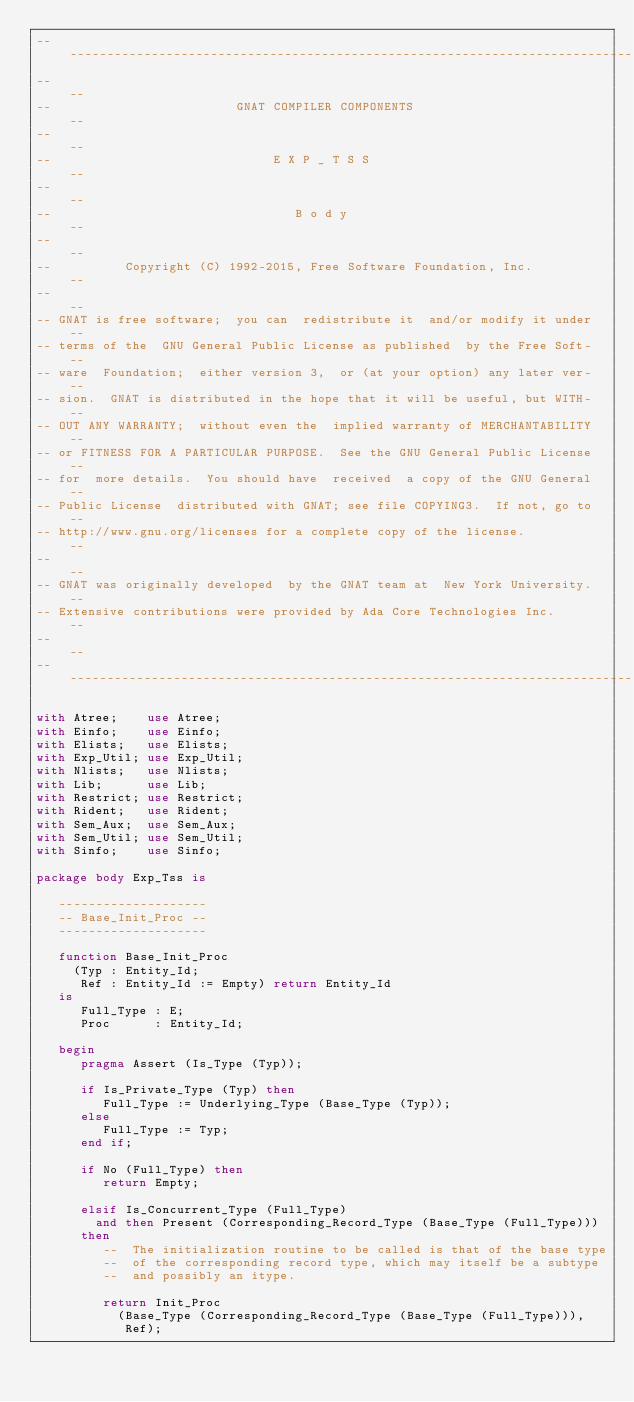<code> <loc_0><loc_0><loc_500><loc_500><_Ada_>------------------------------------------------------------------------------
--                                                                          --
--                         GNAT COMPILER COMPONENTS                         --
--                                                                          --
--                              E X P _ T S S                               --
--                                                                          --
--                                 B o d y                                  --
--                                                                          --
--          Copyright (C) 1992-2015, Free Software Foundation, Inc.         --
--                                                                          --
-- GNAT is free software;  you can  redistribute it  and/or modify it under --
-- terms of the  GNU General Public License as published  by the Free Soft- --
-- ware  Foundation;  either version 3,  or (at your option) any later ver- --
-- sion.  GNAT is distributed in the hope that it will be useful, but WITH- --
-- OUT ANY WARRANTY;  without even the  implied warranty of MERCHANTABILITY --
-- or FITNESS FOR A PARTICULAR PURPOSE.  See the GNU General Public License --
-- for  more details.  You should have  received  a copy of the GNU General --
-- Public License  distributed with GNAT; see file COPYING3.  If not, go to --
-- http://www.gnu.org/licenses for a complete copy of the license.          --
--                                                                          --
-- GNAT was originally developed  by the GNAT team at  New York University. --
-- Extensive contributions were provided by Ada Core Technologies Inc.      --
--                                                                          --
------------------------------------------------------------------------------

with Atree;    use Atree;
with Einfo;    use Einfo;
with Elists;   use Elists;
with Exp_Util; use Exp_Util;
with Nlists;   use Nlists;
with Lib;      use Lib;
with Restrict; use Restrict;
with Rident;   use Rident;
with Sem_Aux;  use Sem_Aux;
with Sem_Util; use Sem_Util;
with Sinfo;    use Sinfo;

package body Exp_Tss is

   --------------------
   -- Base_Init_Proc --
   --------------------

   function Base_Init_Proc
     (Typ : Entity_Id;
      Ref : Entity_Id := Empty) return Entity_Id
   is
      Full_Type : E;
      Proc      : Entity_Id;

   begin
      pragma Assert (Is_Type (Typ));

      if Is_Private_Type (Typ) then
         Full_Type := Underlying_Type (Base_Type (Typ));
      else
         Full_Type := Typ;
      end if;

      if No (Full_Type) then
         return Empty;

      elsif Is_Concurrent_Type (Full_Type)
        and then Present (Corresponding_Record_Type (Base_Type (Full_Type)))
      then
         --  The initialization routine to be called is that of the base type
         --  of the corresponding record type, which may itself be a subtype
         --  and possibly an itype.

         return Init_Proc
           (Base_Type (Corresponding_Record_Type (Base_Type (Full_Type))),
            Ref);
</code> 